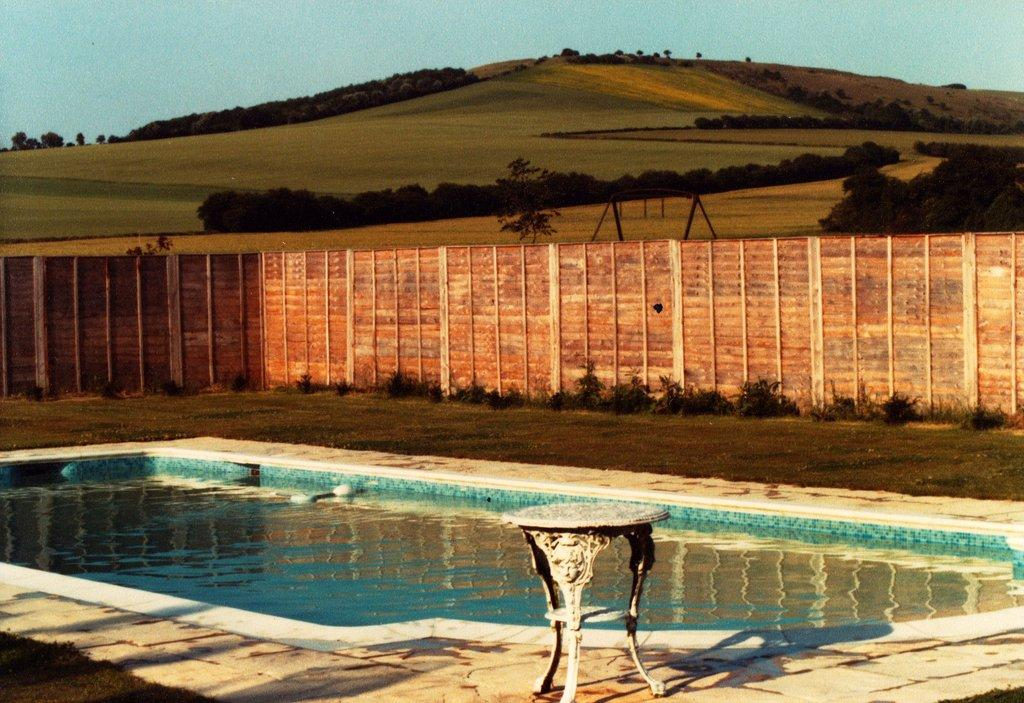What is the main feature in the image? There is a swimming pool in the image. What is located near the swimming pool? There is a fence wall beside the swimming pool. What can be seen in the background of the image? There are trees in the background of the image. How many pizzas are being delivered to the bedroom in the image? There is no mention of pizzas or a bedroom in the image; it features a swimming pool and a fence wall. 